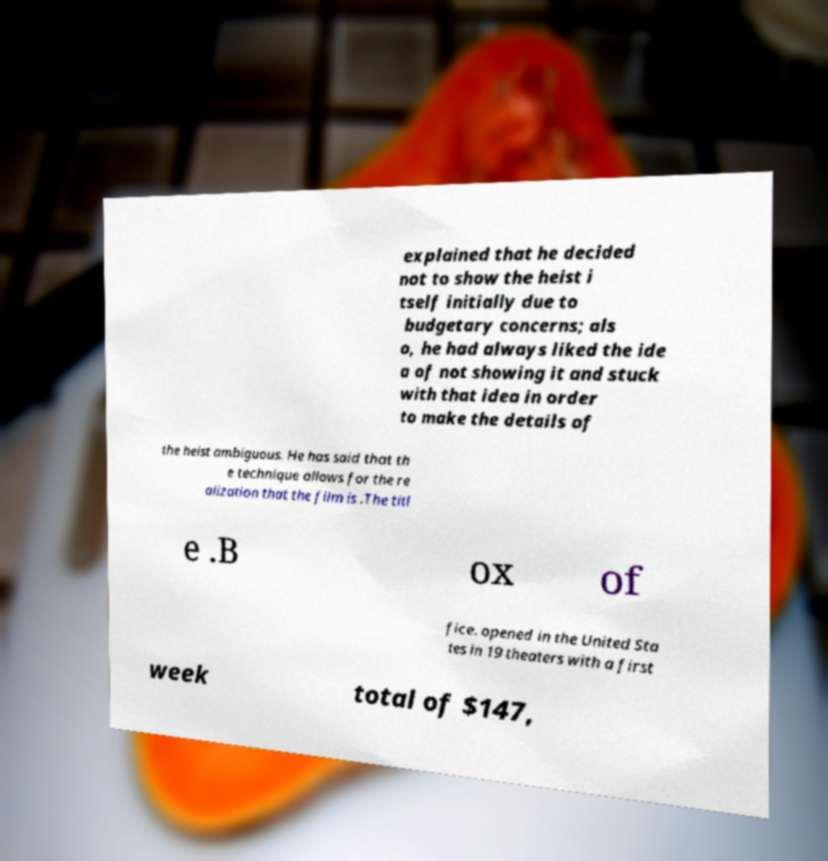For documentation purposes, I need the text within this image transcribed. Could you provide that? explained that he decided not to show the heist i tself initially due to budgetary concerns; als o, he had always liked the ide a of not showing it and stuck with that idea in order to make the details of the heist ambiguous. He has said that th e technique allows for the re alization that the film is .The titl e .B ox of fice. opened in the United Sta tes in 19 theaters with a first week total of $147, 